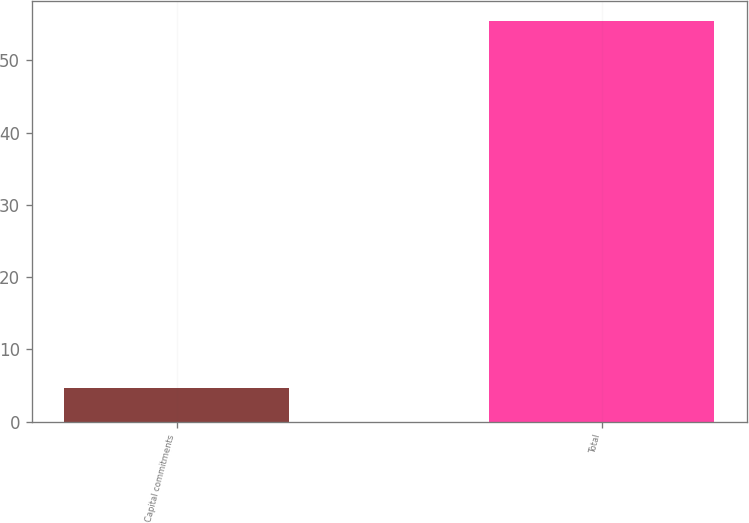<chart> <loc_0><loc_0><loc_500><loc_500><bar_chart><fcel>Capital commitments<fcel>Total<nl><fcel>4.6<fcel>55.4<nl></chart> 